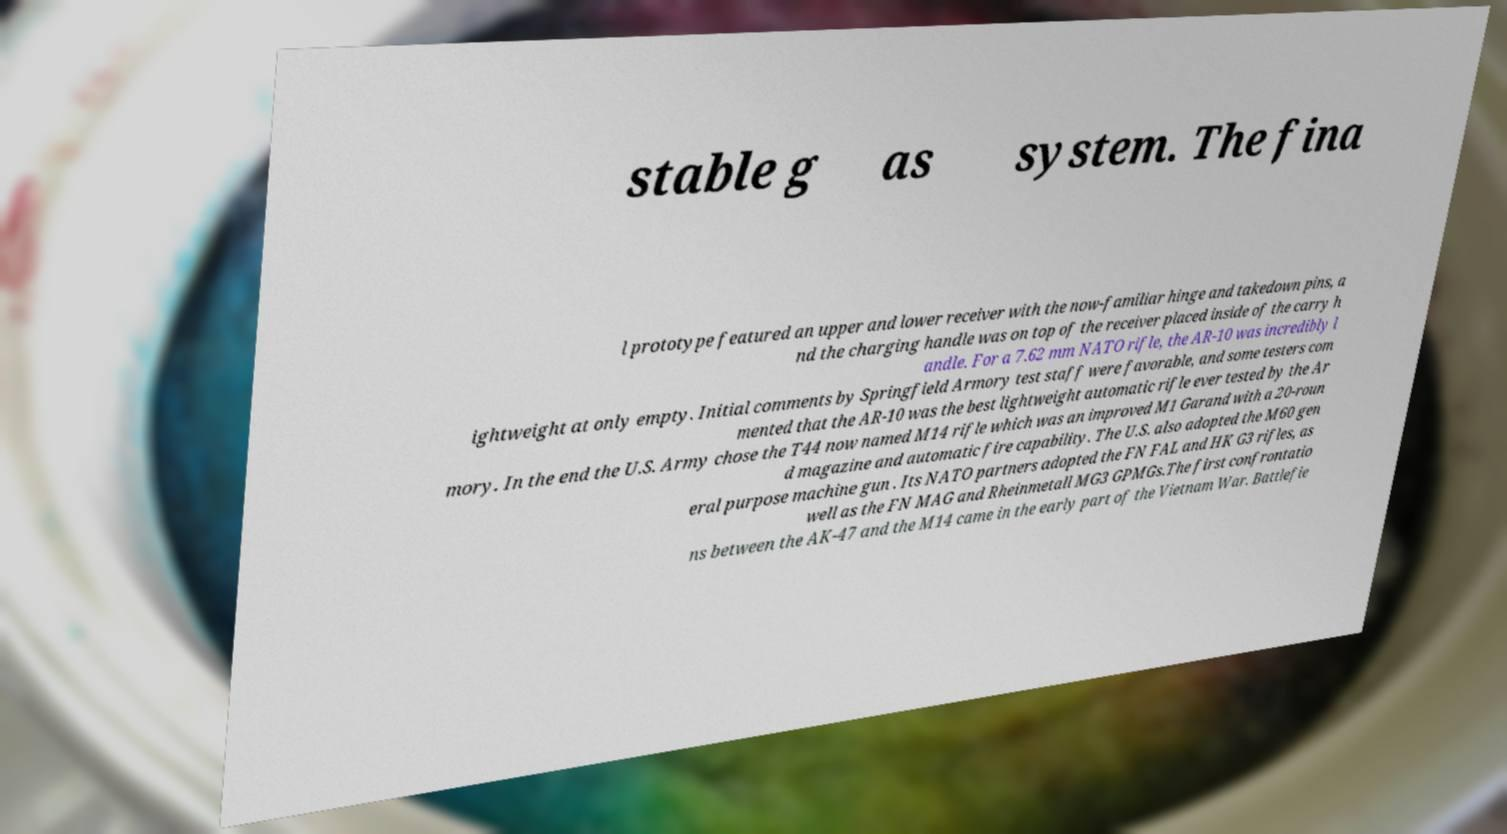What messages or text are displayed in this image? I need them in a readable, typed format. stable g as system. The fina l prototype featured an upper and lower receiver with the now-familiar hinge and takedown pins, a nd the charging handle was on top of the receiver placed inside of the carry h andle. For a 7.62 mm NATO rifle, the AR-10 was incredibly l ightweight at only empty. Initial comments by Springfield Armory test staff were favorable, and some testers com mented that the AR-10 was the best lightweight automatic rifle ever tested by the Ar mory. In the end the U.S. Army chose the T44 now named M14 rifle which was an improved M1 Garand with a 20-roun d magazine and automatic fire capability. The U.S. also adopted the M60 gen eral purpose machine gun . Its NATO partners adopted the FN FAL and HK G3 rifles, as well as the FN MAG and Rheinmetall MG3 GPMGs.The first confrontatio ns between the AK-47 and the M14 came in the early part of the Vietnam War. Battlefie 